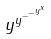Convert formula to latex. <formula><loc_0><loc_0><loc_500><loc_500>y ^ { y ^ { - ^ { - ^ { y ^ { x } } } } }</formula> 